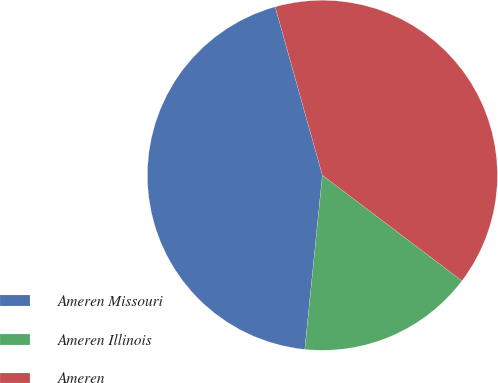Convert chart. <chart><loc_0><loc_0><loc_500><loc_500><pie_chart><fcel>Ameren Missouri<fcel>Ameren Illinois<fcel>Ameren<nl><fcel>44.05%<fcel>16.3%<fcel>39.65%<nl></chart> 